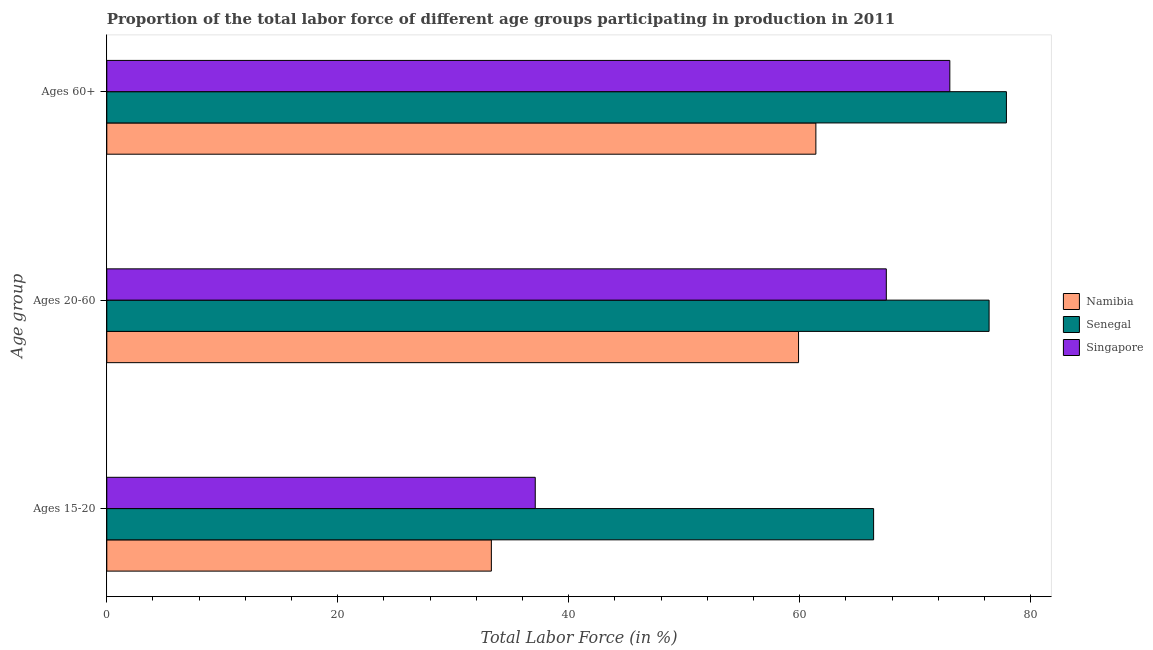How many different coloured bars are there?
Make the answer very short. 3. How many groups of bars are there?
Ensure brevity in your answer.  3. How many bars are there on the 1st tick from the top?
Make the answer very short. 3. How many bars are there on the 1st tick from the bottom?
Your response must be concise. 3. What is the label of the 1st group of bars from the top?
Provide a succinct answer. Ages 60+. What is the percentage of labor force within the age group 15-20 in Singapore?
Provide a short and direct response. 37.1. Across all countries, what is the maximum percentage of labor force above age 60?
Provide a short and direct response. 77.9. Across all countries, what is the minimum percentage of labor force within the age group 15-20?
Provide a short and direct response. 33.3. In which country was the percentage of labor force within the age group 20-60 maximum?
Your answer should be very brief. Senegal. In which country was the percentage of labor force above age 60 minimum?
Your answer should be compact. Namibia. What is the total percentage of labor force within the age group 15-20 in the graph?
Give a very brief answer. 136.8. What is the difference between the percentage of labor force within the age group 15-20 in Namibia and that in Senegal?
Offer a very short reply. -33.1. What is the difference between the percentage of labor force above age 60 in Namibia and the percentage of labor force within the age group 15-20 in Singapore?
Provide a succinct answer. 24.3. What is the average percentage of labor force above age 60 per country?
Your answer should be very brief. 70.77. What is the difference between the percentage of labor force above age 60 and percentage of labor force within the age group 15-20 in Namibia?
Provide a succinct answer. 28.1. What is the ratio of the percentage of labor force within the age group 15-20 in Namibia to that in Senegal?
Your answer should be compact. 0.5. Is the percentage of labor force within the age group 20-60 in Singapore less than that in Namibia?
Your answer should be compact. No. What is the difference between the highest and the second highest percentage of labor force within the age group 15-20?
Your answer should be very brief. 29.3. What is the difference between the highest and the lowest percentage of labor force above age 60?
Provide a succinct answer. 16.5. Is the sum of the percentage of labor force within the age group 20-60 in Namibia and Senegal greater than the maximum percentage of labor force within the age group 15-20 across all countries?
Your answer should be very brief. Yes. What does the 1st bar from the top in Ages 60+ represents?
Provide a short and direct response. Singapore. What does the 1st bar from the bottom in Ages 60+ represents?
Your answer should be compact. Namibia. Is it the case that in every country, the sum of the percentage of labor force within the age group 15-20 and percentage of labor force within the age group 20-60 is greater than the percentage of labor force above age 60?
Give a very brief answer. Yes. How many bars are there?
Make the answer very short. 9. Are all the bars in the graph horizontal?
Provide a succinct answer. Yes. What is the difference between two consecutive major ticks on the X-axis?
Your answer should be very brief. 20. Are the values on the major ticks of X-axis written in scientific E-notation?
Provide a short and direct response. No. Does the graph contain any zero values?
Offer a terse response. No. Does the graph contain grids?
Your answer should be compact. No. Where does the legend appear in the graph?
Offer a terse response. Center right. How are the legend labels stacked?
Your response must be concise. Vertical. What is the title of the graph?
Offer a terse response. Proportion of the total labor force of different age groups participating in production in 2011. What is the label or title of the Y-axis?
Your answer should be very brief. Age group. What is the Total Labor Force (in %) of Namibia in Ages 15-20?
Make the answer very short. 33.3. What is the Total Labor Force (in %) of Senegal in Ages 15-20?
Provide a short and direct response. 66.4. What is the Total Labor Force (in %) of Singapore in Ages 15-20?
Provide a succinct answer. 37.1. What is the Total Labor Force (in %) in Namibia in Ages 20-60?
Your response must be concise. 59.9. What is the Total Labor Force (in %) of Senegal in Ages 20-60?
Your answer should be very brief. 76.4. What is the Total Labor Force (in %) in Singapore in Ages 20-60?
Provide a short and direct response. 67.5. What is the Total Labor Force (in %) of Namibia in Ages 60+?
Keep it short and to the point. 61.4. What is the Total Labor Force (in %) in Senegal in Ages 60+?
Your answer should be very brief. 77.9. Across all Age group, what is the maximum Total Labor Force (in %) in Namibia?
Your answer should be very brief. 61.4. Across all Age group, what is the maximum Total Labor Force (in %) of Senegal?
Your answer should be very brief. 77.9. Across all Age group, what is the minimum Total Labor Force (in %) of Namibia?
Keep it short and to the point. 33.3. Across all Age group, what is the minimum Total Labor Force (in %) of Senegal?
Your response must be concise. 66.4. Across all Age group, what is the minimum Total Labor Force (in %) in Singapore?
Keep it short and to the point. 37.1. What is the total Total Labor Force (in %) in Namibia in the graph?
Keep it short and to the point. 154.6. What is the total Total Labor Force (in %) of Senegal in the graph?
Your answer should be very brief. 220.7. What is the total Total Labor Force (in %) of Singapore in the graph?
Offer a very short reply. 177.6. What is the difference between the Total Labor Force (in %) of Namibia in Ages 15-20 and that in Ages 20-60?
Keep it short and to the point. -26.6. What is the difference between the Total Labor Force (in %) in Senegal in Ages 15-20 and that in Ages 20-60?
Your response must be concise. -10. What is the difference between the Total Labor Force (in %) in Singapore in Ages 15-20 and that in Ages 20-60?
Give a very brief answer. -30.4. What is the difference between the Total Labor Force (in %) of Namibia in Ages 15-20 and that in Ages 60+?
Ensure brevity in your answer.  -28.1. What is the difference between the Total Labor Force (in %) of Singapore in Ages 15-20 and that in Ages 60+?
Offer a very short reply. -35.9. What is the difference between the Total Labor Force (in %) of Senegal in Ages 20-60 and that in Ages 60+?
Keep it short and to the point. -1.5. What is the difference between the Total Labor Force (in %) of Singapore in Ages 20-60 and that in Ages 60+?
Provide a short and direct response. -5.5. What is the difference between the Total Labor Force (in %) of Namibia in Ages 15-20 and the Total Labor Force (in %) of Senegal in Ages 20-60?
Ensure brevity in your answer.  -43.1. What is the difference between the Total Labor Force (in %) in Namibia in Ages 15-20 and the Total Labor Force (in %) in Singapore in Ages 20-60?
Offer a terse response. -34.2. What is the difference between the Total Labor Force (in %) of Namibia in Ages 15-20 and the Total Labor Force (in %) of Senegal in Ages 60+?
Your response must be concise. -44.6. What is the difference between the Total Labor Force (in %) of Namibia in Ages 15-20 and the Total Labor Force (in %) of Singapore in Ages 60+?
Ensure brevity in your answer.  -39.7. What is the difference between the Total Labor Force (in %) in Senegal in Ages 15-20 and the Total Labor Force (in %) in Singapore in Ages 60+?
Offer a very short reply. -6.6. What is the difference between the Total Labor Force (in %) of Senegal in Ages 20-60 and the Total Labor Force (in %) of Singapore in Ages 60+?
Make the answer very short. 3.4. What is the average Total Labor Force (in %) in Namibia per Age group?
Your answer should be compact. 51.53. What is the average Total Labor Force (in %) in Senegal per Age group?
Provide a short and direct response. 73.57. What is the average Total Labor Force (in %) of Singapore per Age group?
Offer a very short reply. 59.2. What is the difference between the Total Labor Force (in %) in Namibia and Total Labor Force (in %) in Senegal in Ages 15-20?
Offer a terse response. -33.1. What is the difference between the Total Labor Force (in %) in Namibia and Total Labor Force (in %) in Singapore in Ages 15-20?
Offer a terse response. -3.8. What is the difference between the Total Labor Force (in %) in Senegal and Total Labor Force (in %) in Singapore in Ages 15-20?
Your response must be concise. 29.3. What is the difference between the Total Labor Force (in %) in Namibia and Total Labor Force (in %) in Senegal in Ages 20-60?
Provide a succinct answer. -16.5. What is the difference between the Total Labor Force (in %) of Namibia and Total Labor Force (in %) of Senegal in Ages 60+?
Offer a terse response. -16.5. What is the ratio of the Total Labor Force (in %) of Namibia in Ages 15-20 to that in Ages 20-60?
Ensure brevity in your answer.  0.56. What is the ratio of the Total Labor Force (in %) in Senegal in Ages 15-20 to that in Ages 20-60?
Offer a very short reply. 0.87. What is the ratio of the Total Labor Force (in %) of Singapore in Ages 15-20 to that in Ages 20-60?
Offer a very short reply. 0.55. What is the ratio of the Total Labor Force (in %) in Namibia in Ages 15-20 to that in Ages 60+?
Provide a short and direct response. 0.54. What is the ratio of the Total Labor Force (in %) in Senegal in Ages 15-20 to that in Ages 60+?
Keep it short and to the point. 0.85. What is the ratio of the Total Labor Force (in %) of Singapore in Ages 15-20 to that in Ages 60+?
Provide a succinct answer. 0.51. What is the ratio of the Total Labor Force (in %) of Namibia in Ages 20-60 to that in Ages 60+?
Keep it short and to the point. 0.98. What is the ratio of the Total Labor Force (in %) of Senegal in Ages 20-60 to that in Ages 60+?
Your response must be concise. 0.98. What is the ratio of the Total Labor Force (in %) in Singapore in Ages 20-60 to that in Ages 60+?
Your response must be concise. 0.92. What is the difference between the highest and the second highest Total Labor Force (in %) in Namibia?
Your answer should be compact. 1.5. What is the difference between the highest and the second highest Total Labor Force (in %) of Senegal?
Give a very brief answer. 1.5. What is the difference between the highest and the second highest Total Labor Force (in %) in Singapore?
Keep it short and to the point. 5.5. What is the difference between the highest and the lowest Total Labor Force (in %) of Namibia?
Your answer should be compact. 28.1. What is the difference between the highest and the lowest Total Labor Force (in %) of Senegal?
Your answer should be compact. 11.5. What is the difference between the highest and the lowest Total Labor Force (in %) in Singapore?
Your answer should be very brief. 35.9. 